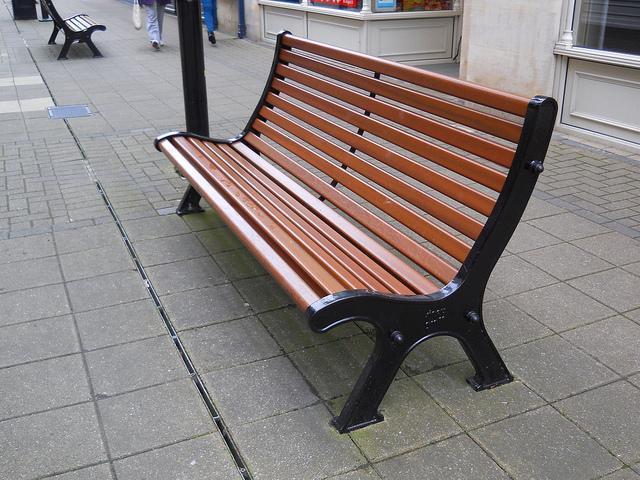This bench is located where?
Pick the right solution, then justify: 'Answer: answer
Rationale: rationale.'
Options: Ocean front, city sidewalk, mall, park. Answer: city sidewalk.
Rationale: This particularly well-maintained bench is on an equally spotless city sidewalk. made popular in paris in the 1850s, park benches are a part of most major cities to this day. 